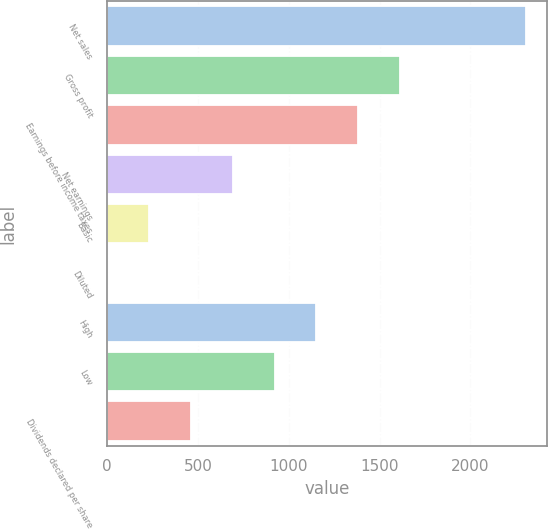<chart> <loc_0><loc_0><loc_500><loc_500><bar_chart><fcel>Net sales<fcel>Gross profit<fcel>Earnings before income taxes<fcel>Net earnings<fcel>Basic<fcel>Diluted<fcel>High<fcel>Low<fcel>Dividends declared per share<nl><fcel>2305<fcel>1613.54<fcel>1383.06<fcel>691.62<fcel>230.66<fcel>0.18<fcel>1152.58<fcel>922.1<fcel>461.14<nl></chart> 